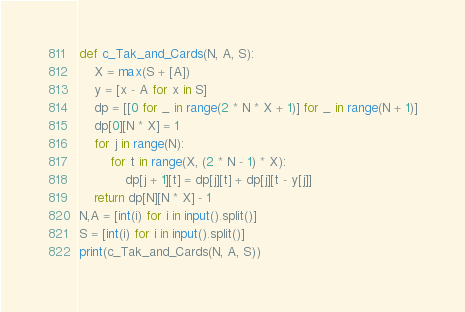Convert code to text. <code><loc_0><loc_0><loc_500><loc_500><_Python_>def c_Tak_and_Cards(N, A, S):
    X = max(S + [A])
    y = [x - A for x in S]
    dp = [[0 for _ in range(2 * N * X + 1)] for _ in range(N + 1)]
    dp[0][N * X] = 1
    for j in range(N):
        for t in range(X, (2 * N - 1) * X):
            dp[j + 1][t] = dp[j][t] + dp[j][t - y[j]]
    return dp[N][N * X] - 1
N,A = [int(i) for i in input().split()]
S = [int(i) for i in input().split()]
print(c_Tak_and_Cards(N, A, S))</code> 